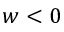Convert formula to latex. <formula><loc_0><loc_0><loc_500><loc_500>w < 0</formula> 